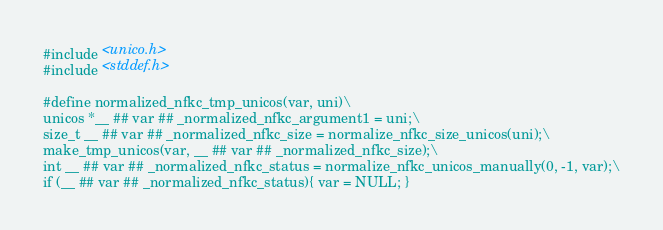Convert code to text. <code><loc_0><loc_0><loc_500><loc_500><_C_>#include <unico.h>
#include <stddef.h>

#define normalized_nfkc_tmp_unicos(var, uni)\
unicos *__ ## var ## _normalized_nfkc_argument1 = uni;\
size_t __ ## var ## _normalized_nfkc_size = normalize_nfkc_size_unicos(uni);\
make_tmp_unicos(var, __ ## var ## _normalized_nfkc_size);\
int __ ## var ## _normalized_nfkc_status = normalize_nfkc_unicos_manually(0, -1, var);\
if (__ ## var ## _normalized_nfkc_status){ var = NULL; }
</code> 